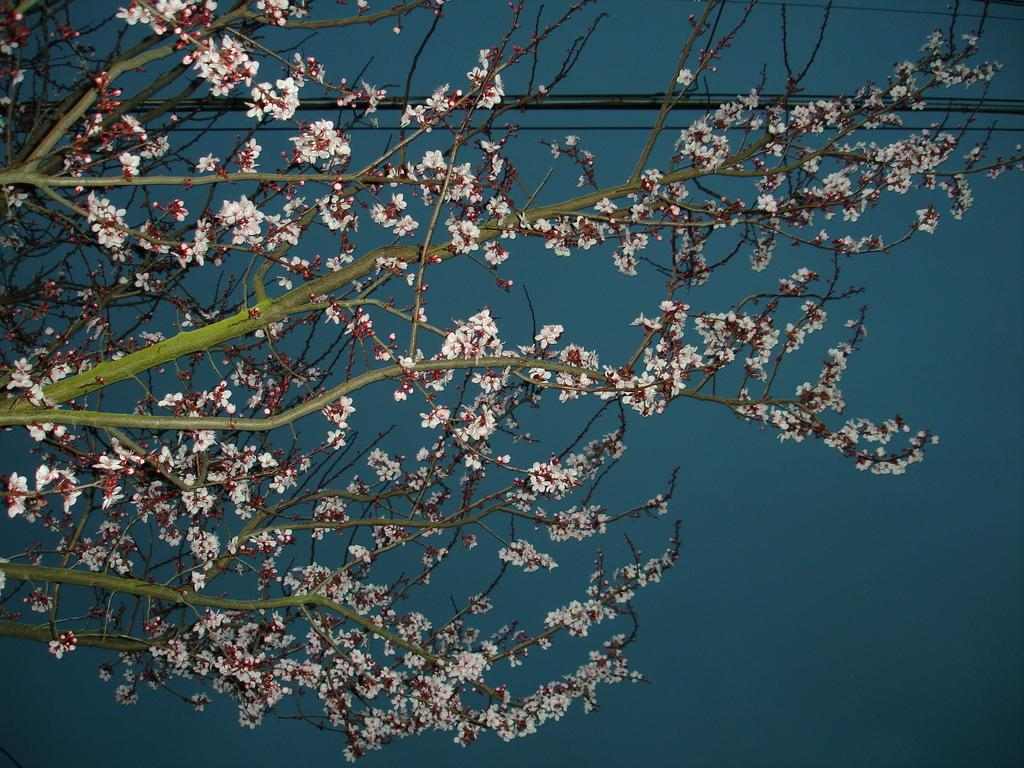What is present in the image that is related to nature? There is a branch in the image. What else can be seen in the image besides the branch? There is a wire in the image. What color is the background of the image? The background of the image is blue. How many grains of sand are visible on the branch in the image? There are no grains of sand visible on the branch in the image. Can you describe the type of kiss that is happening between the branch and the wire in the image? There is no kiss happening between the branch and the wire in the image; they are separate objects. 